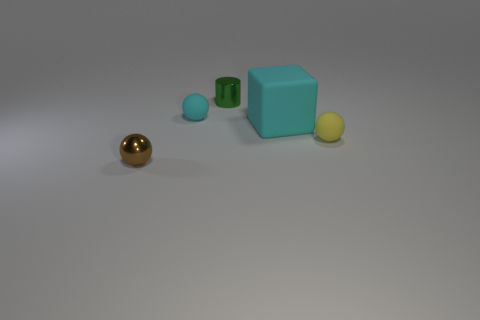Add 3 large gray shiny spheres. How many objects exist? 8 Subtract all blocks. How many objects are left? 4 Add 5 large yellow things. How many large yellow things exist? 5 Subtract 0 red balls. How many objects are left? 5 Subtract all big matte objects. Subtract all tiny red rubber objects. How many objects are left? 4 Add 4 cylinders. How many cylinders are left? 5 